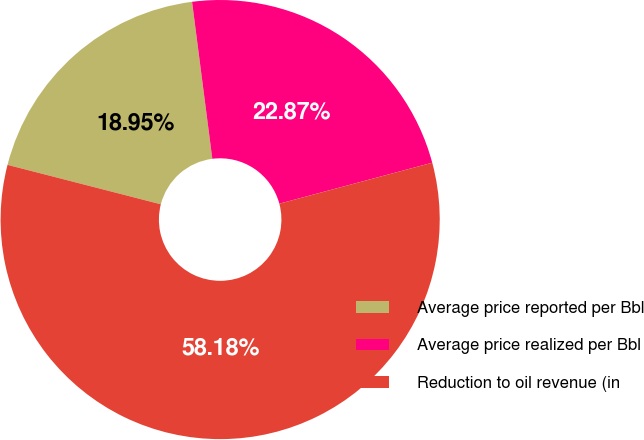Convert chart. <chart><loc_0><loc_0><loc_500><loc_500><pie_chart><fcel>Average price reported per Bbl<fcel>Average price realized per Bbl<fcel>Reduction to oil revenue (in<nl><fcel>18.95%<fcel>22.87%<fcel>58.17%<nl></chart> 